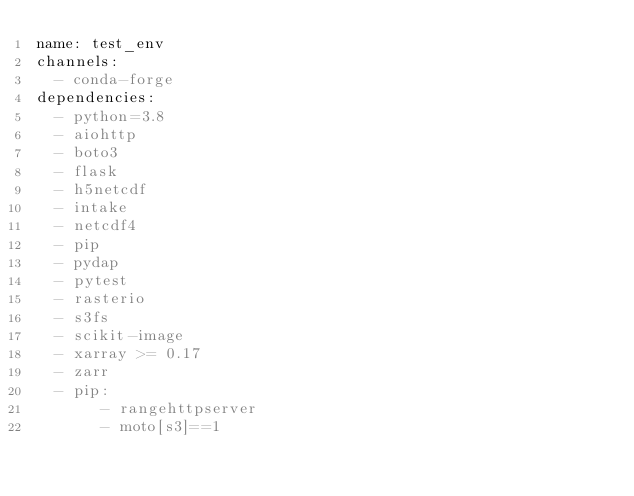<code> <loc_0><loc_0><loc_500><loc_500><_YAML_>name: test_env
channels:
  - conda-forge
dependencies:
  - python=3.8
  - aiohttp
  - boto3
  - flask
  - h5netcdf
  - intake
  - netcdf4
  - pip
  - pydap
  - pytest
  - rasterio
  - s3fs
  - scikit-image
  - xarray >= 0.17
  - zarr
  - pip:
       - rangehttpserver
       - moto[s3]==1
</code> 